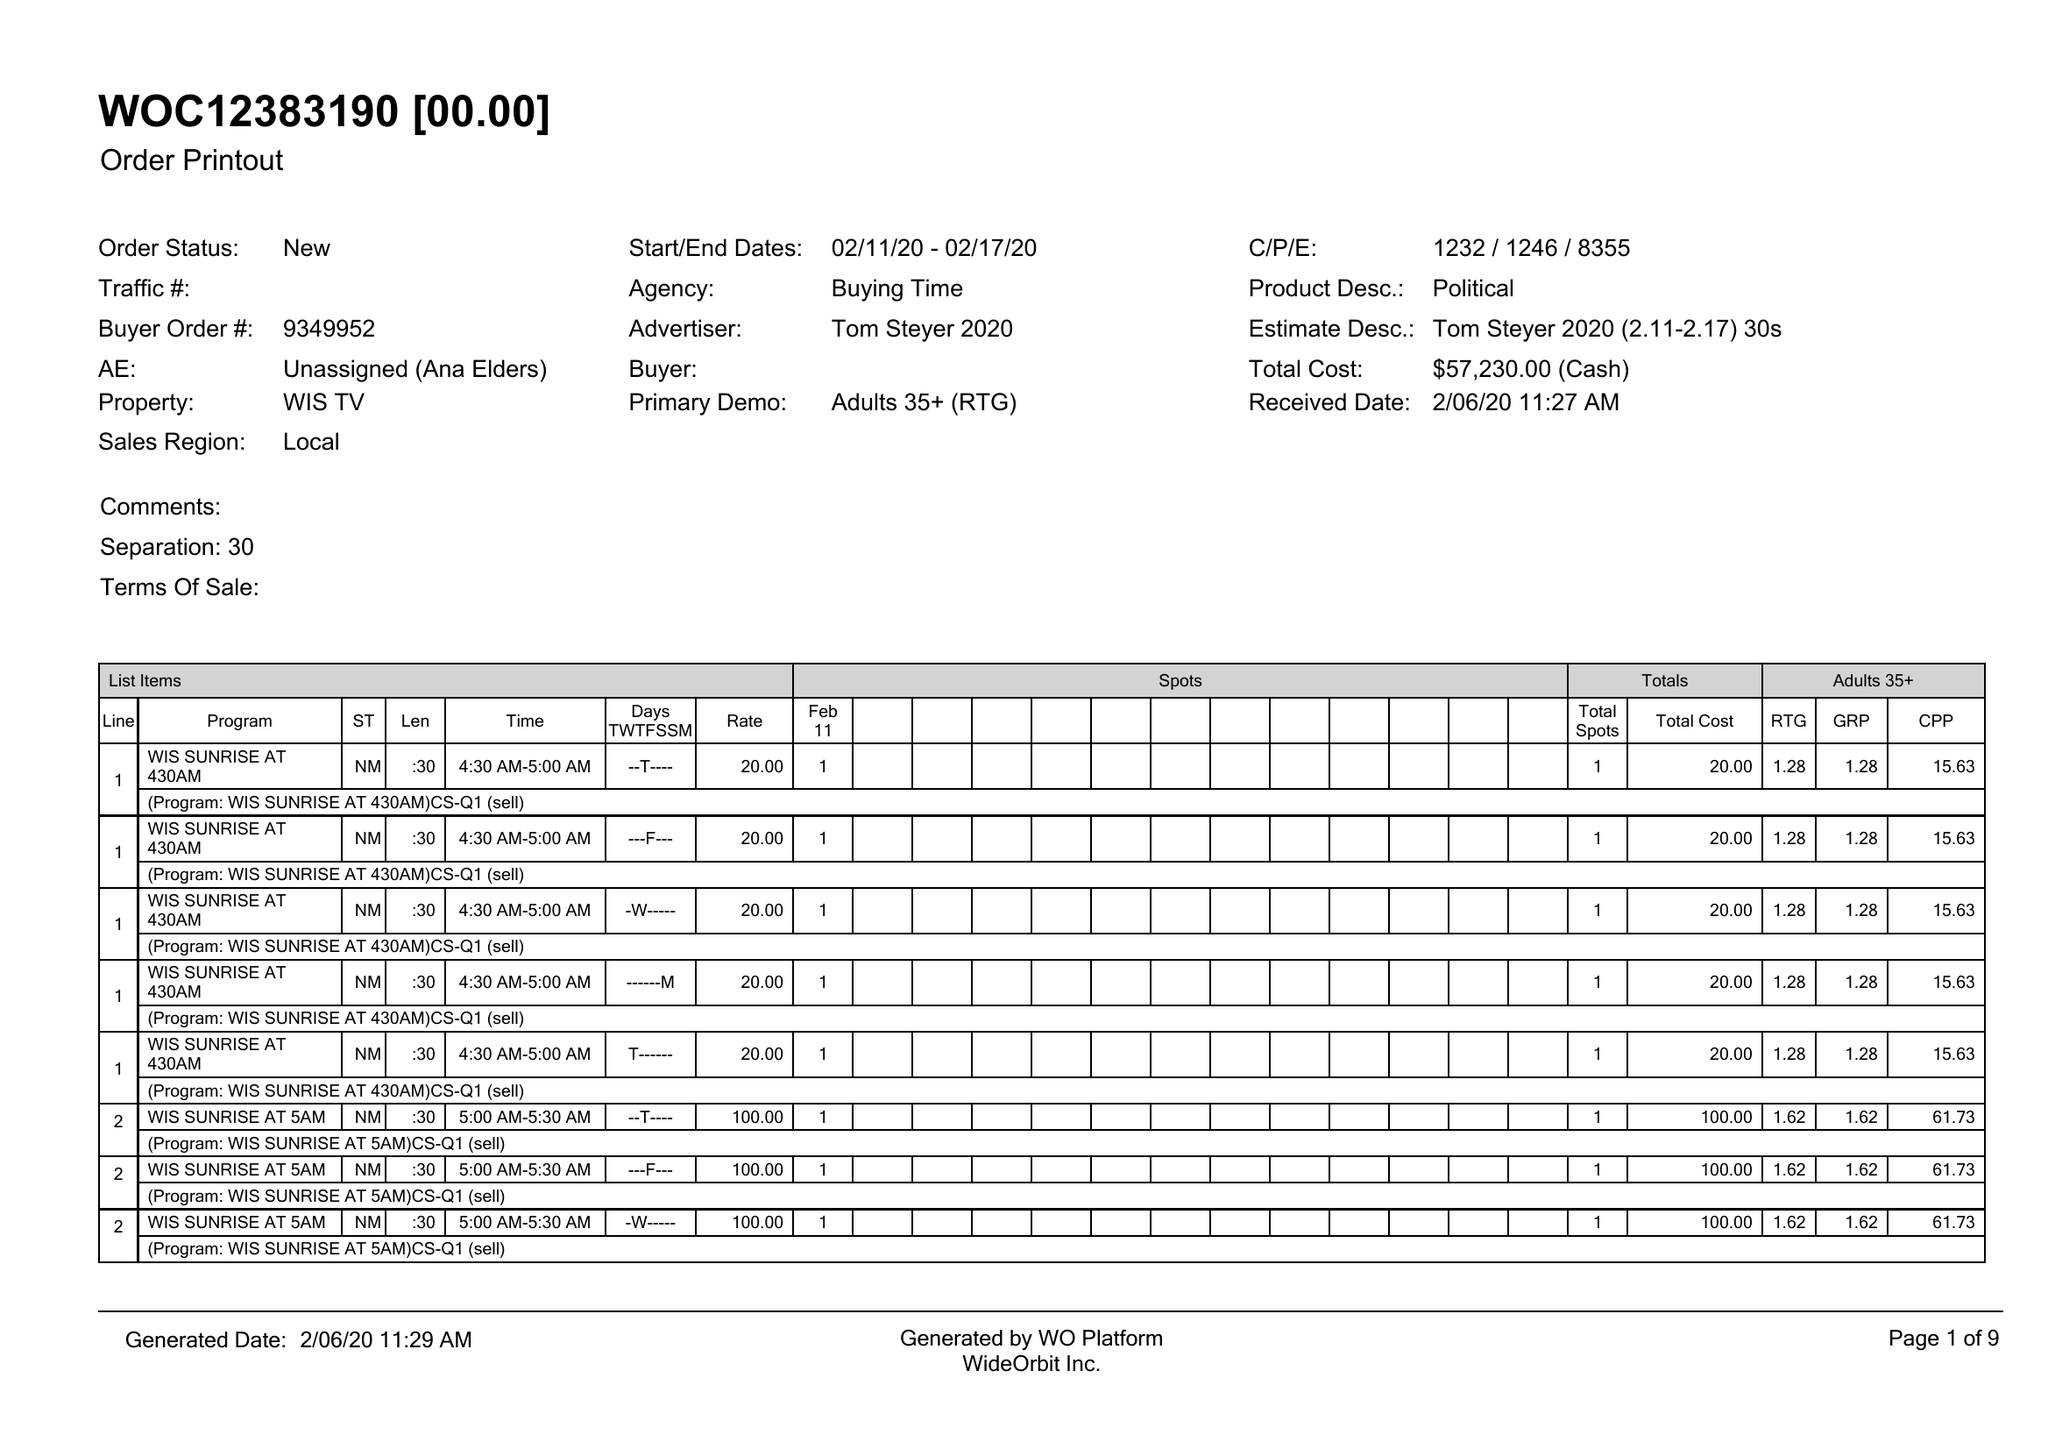What is the value for the advertiser?
Answer the question using a single word or phrase. TOM STEYER 2020 